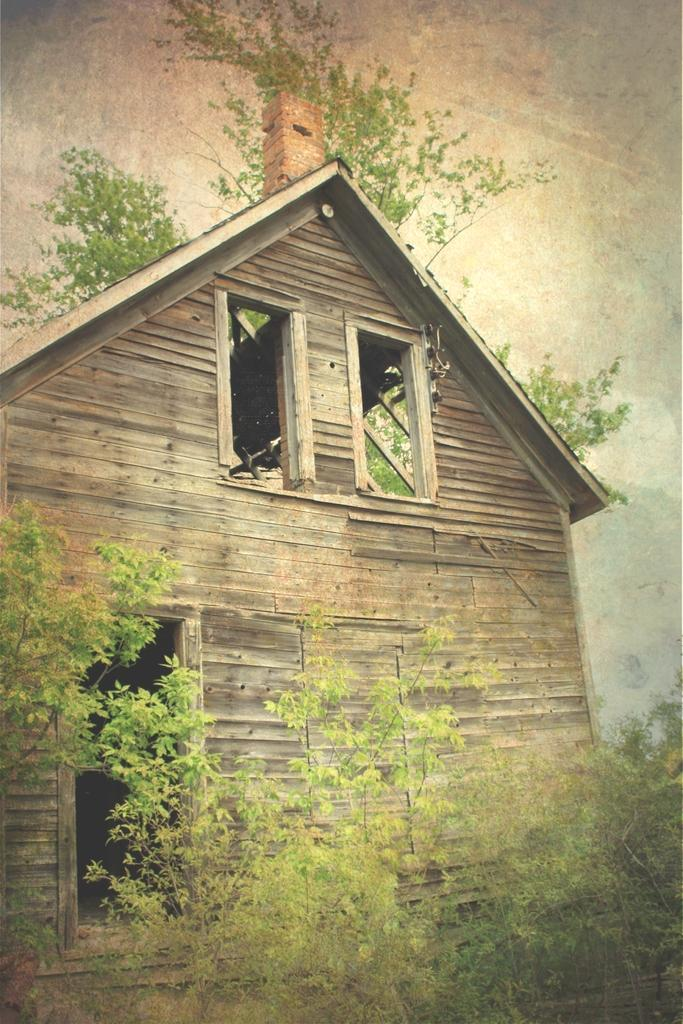What type of vegetation is at the bottom of the image? There are trees at the bottom of the image. What structure is located in the middle of the image? There is a wooden hut in the middle of the image. What can be seen in the background of the image? There are trees in the background of the image. What is visible at the top of the image? The sky is visible at the top of the image. How many doors are visible on the wooden hut in the image? There is no information about doors on the wooden hut in the provided facts, so we cannot determine the number of doors. What type of light is illuminating the wooden hut in the image? There is no information about light sources in the provided facts, so we cannot determine the type of light illuminating the wooden hut. 